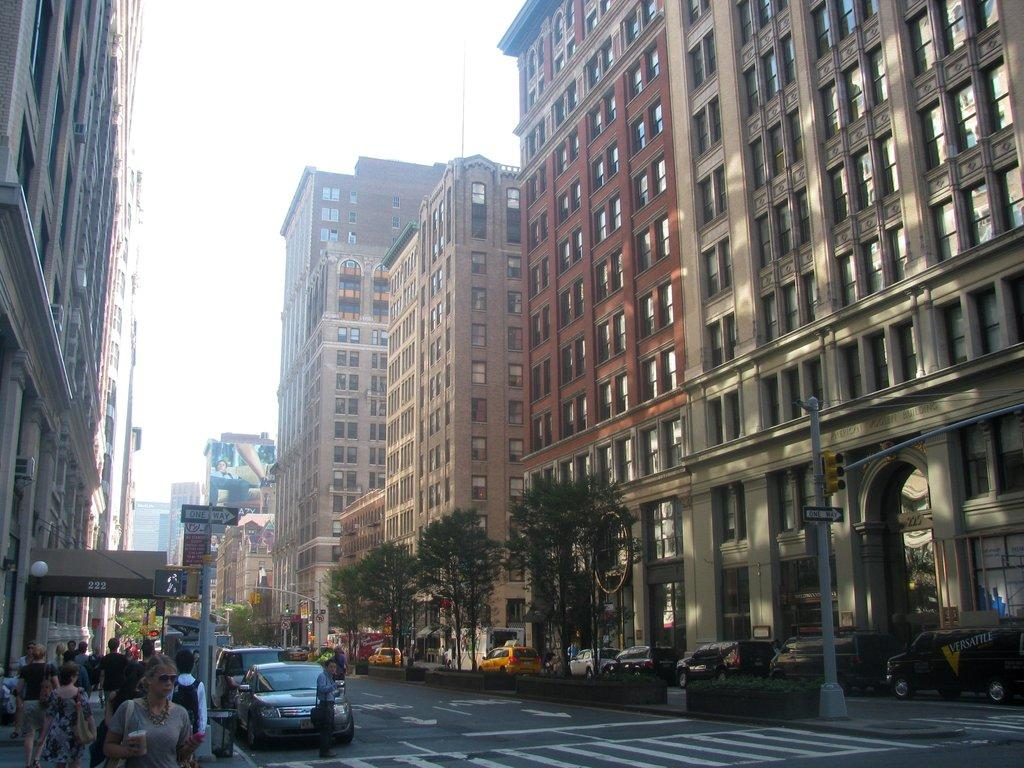What is happening on the road in the image? Vehicles are moving on the road. What are people doing on the footpath? People are walking on the footpath. What is in the middle of the road? There are trees in the middle of the road. What can be seen on either side of the road? There are buildings on either side of the road. What type of pie is being served at the restaurant in the image? There is no restaurant or pie present in the image; it features vehicles moving on the road and people walking on the footpath. How many cats can be seen playing on the trees in the image? There are no cats present in the image; it features trees in the middle of the road. 